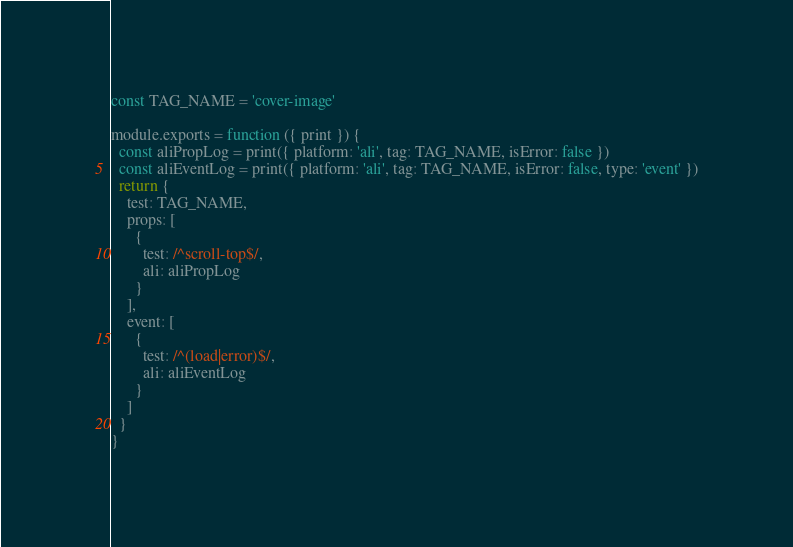<code> <loc_0><loc_0><loc_500><loc_500><_JavaScript_>const TAG_NAME = 'cover-image'

module.exports = function ({ print }) {
  const aliPropLog = print({ platform: 'ali', tag: TAG_NAME, isError: false })
  const aliEventLog = print({ platform: 'ali', tag: TAG_NAME, isError: false, type: 'event' })
  return {
    test: TAG_NAME,
    props: [
      {
        test: /^scroll-top$/,
        ali: aliPropLog
      }
    ],
    event: [
      {
        test: /^(load|error)$/,
        ali: aliEventLog
      }
    ]
  }
}
</code> 